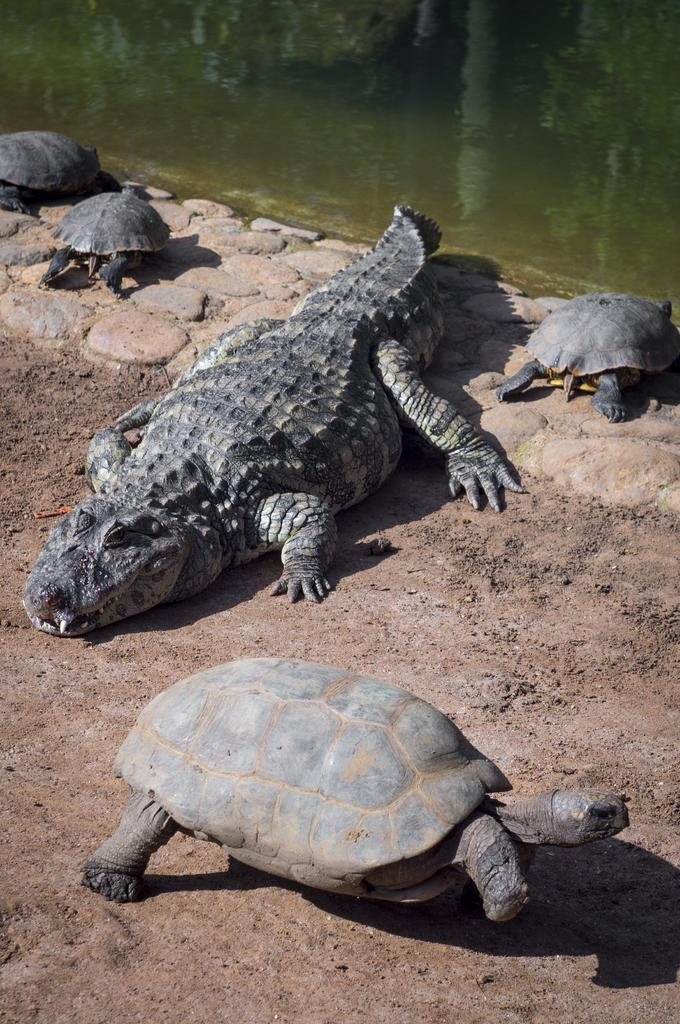What type of animals can be seen in the image? There are tortoises and a crocodile in the image. What is the primary setting in which these animals are situated? There is a pond in the image. What type of sand can be seen in the image? There is no sand present in the image. What time of day is depicted in the image? The time of day cannot be determined from the image. 